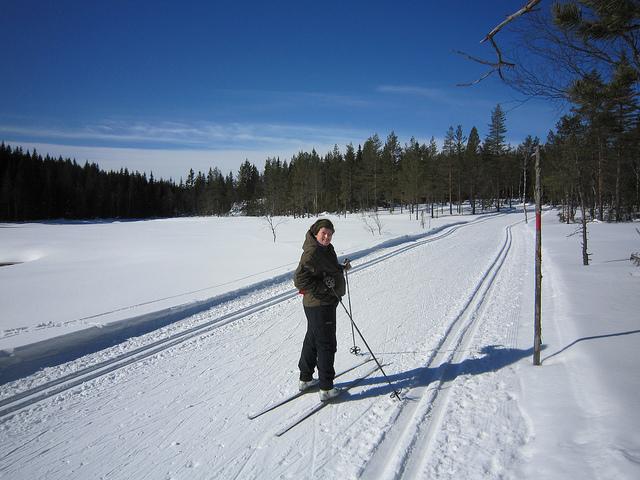How many lines are in the snow?
Give a very brief answer. 4. How many paths in the snow?
Keep it brief. 2. Is the ground flat?
Keep it brief. Yes. How many ski tracks are visible?
Short answer required. 2. Which direction is the sun?
Concise answer only. Left. What color is the girl's pants?
Short answer required. Black. How many people are there?
Write a very short answer. 1. 